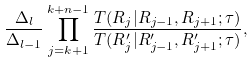Convert formula to latex. <formula><loc_0><loc_0><loc_500><loc_500>\frac { \Delta _ { l } } { \Delta _ { l - 1 } } \prod _ { j = k + 1 } ^ { k + n - 1 } \frac { T ( R _ { j } | R _ { j - 1 } , R _ { j + 1 } ; \tau ) } { T ( R ^ { \prime } _ { j } | R ^ { \prime } _ { j - 1 } , R ^ { \prime } _ { j + 1 } ; \tau ) } ,</formula> 